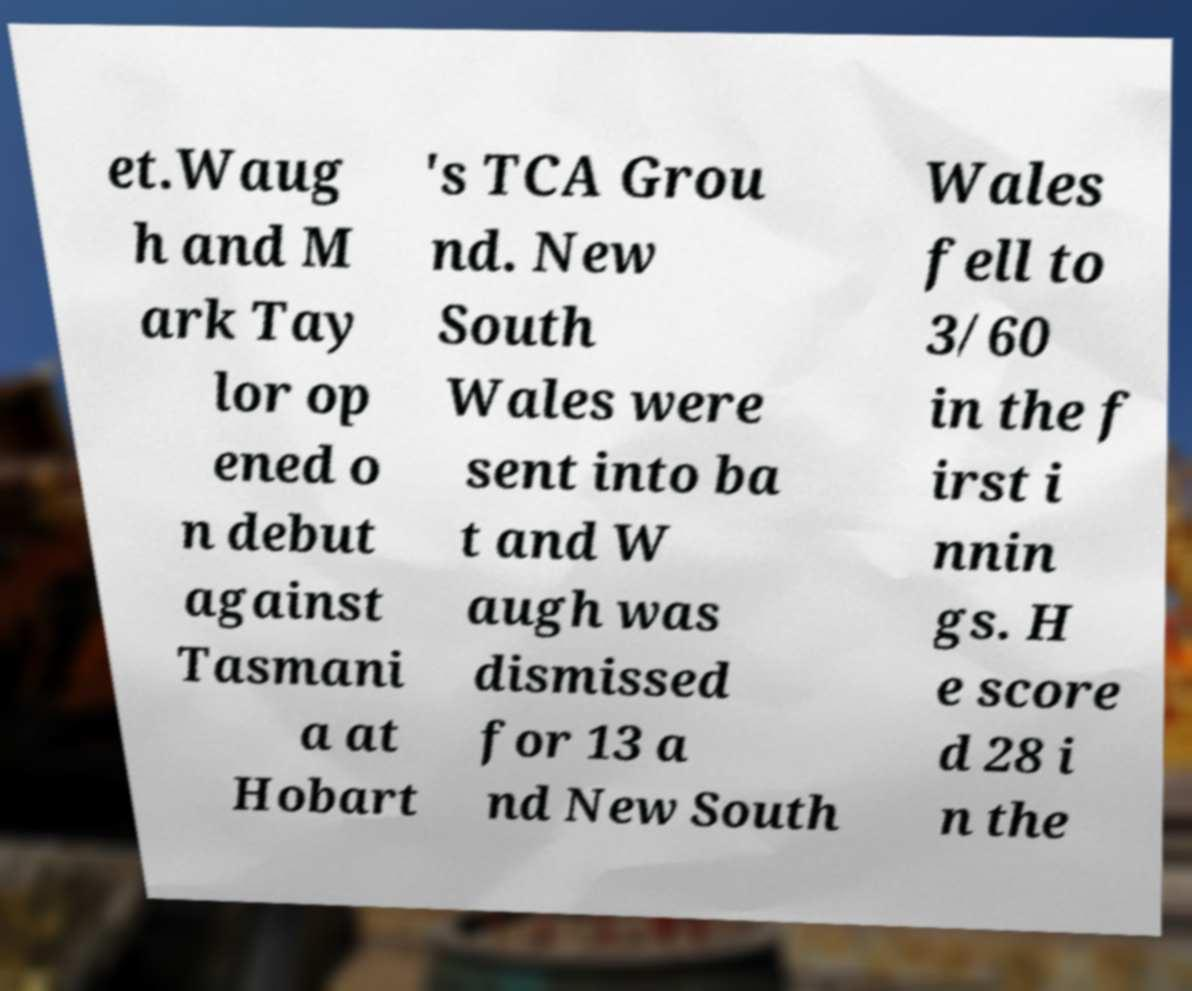Could you extract and type out the text from this image? et.Waug h and M ark Tay lor op ened o n debut against Tasmani a at Hobart 's TCA Grou nd. New South Wales were sent into ba t and W augh was dismissed for 13 a nd New South Wales fell to 3/60 in the f irst i nnin gs. H e score d 28 i n the 